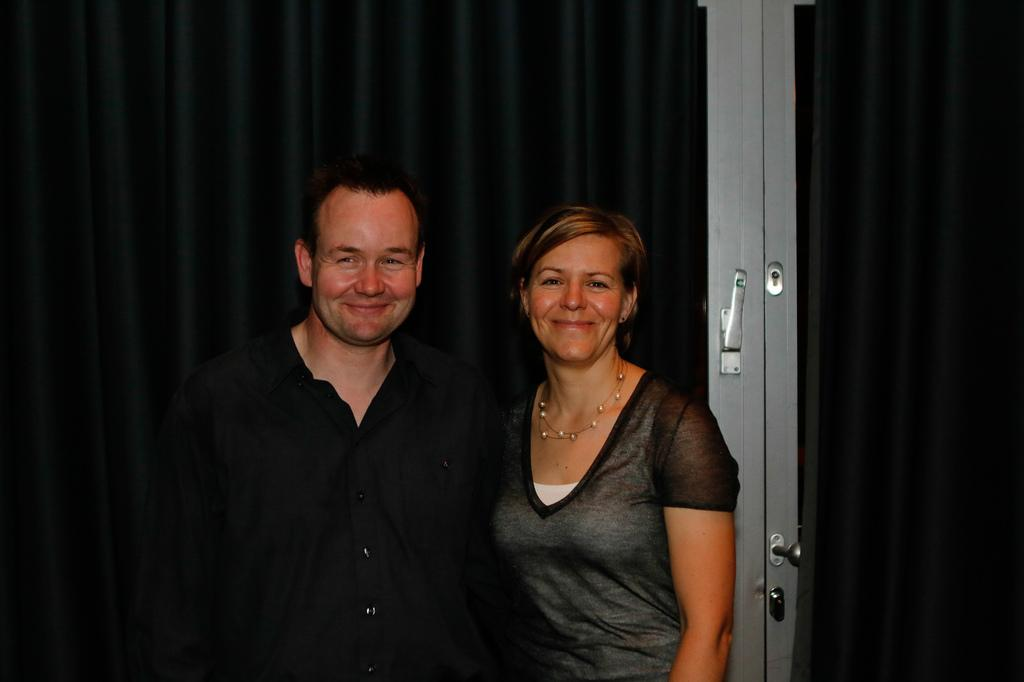How many people are in the image? There is a man and a woman in the image. What are the people in the image doing? Both the man and the woman are standing and smiling. What can be seen near the people in the image? There is a door in the image. Can you describe the door in the image? The door has a lock and a handle. What else is visible in the image? There is a black color cloth hanging in the image. Is there any blood visible on the door in the image? No, there is no blood visible on the door in the image. What is the location of the scene in the image, such as downtown or a residential area? The provided facts do not give any information about the location of the scene in the image. 